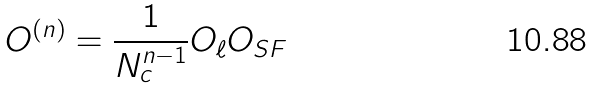Convert formula to latex. <formula><loc_0><loc_0><loc_500><loc_500>O ^ { ( n ) } = \frac { 1 } { N _ { c } ^ { n - 1 } } O _ { \ell } O _ { S F }</formula> 